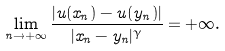<formula> <loc_0><loc_0><loc_500><loc_500>\lim _ { n \to + \infty } \frac { | u ( x _ { n } ) - u ( y _ { n } ) | } { | x _ { n } - y _ { n } | ^ { \gamma } } = + \infty .</formula> 